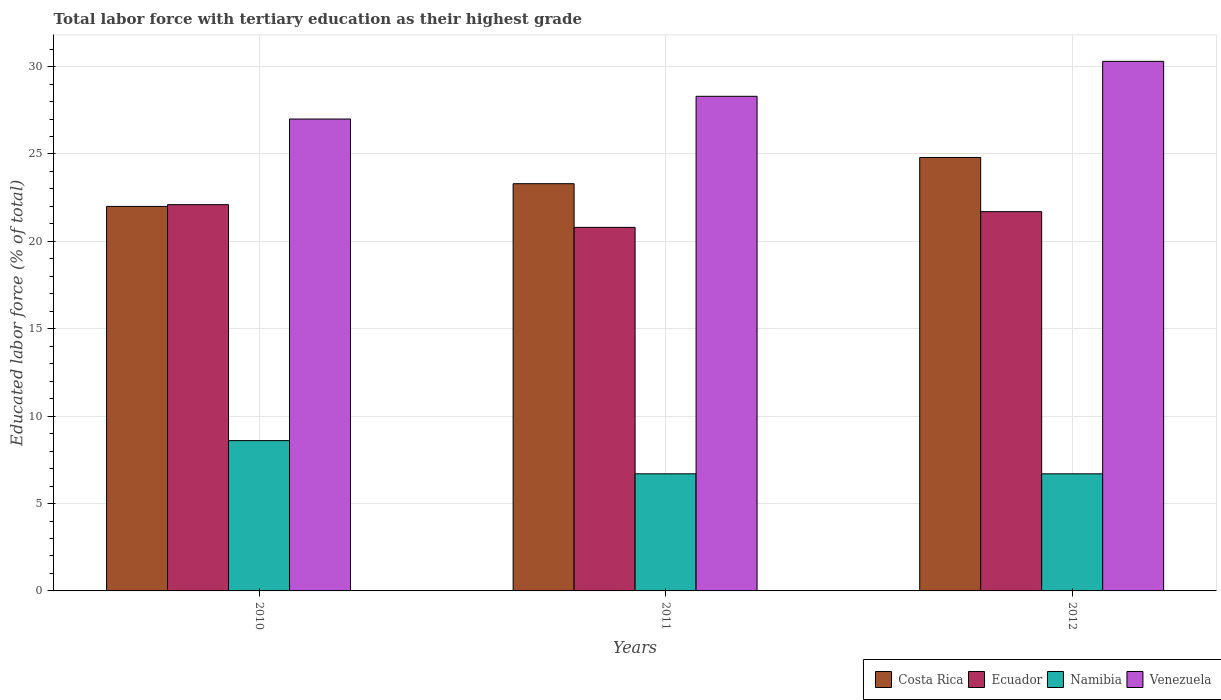How many different coloured bars are there?
Your response must be concise. 4. Are the number of bars on each tick of the X-axis equal?
Make the answer very short. Yes. What is the label of the 3rd group of bars from the left?
Ensure brevity in your answer.  2012. What is the percentage of male labor force with tertiary education in Ecuador in 2011?
Provide a short and direct response. 20.8. Across all years, what is the maximum percentage of male labor force with tertiary education in Venezuela?
Provide a short and direct response. 30.3. Across all years, what is the minimum percentage of male labor force with tertiary education in Ecuador?
Offer a terse response. 20.8. In which year was the percentage of male labor force with tertiary education in Venezuela maximum?
Your answer should be compact. 2012. In which year was the percentage of male labor force with tertiary education in Namibia minimum?
Ensure brevity in your answer.  2011. What is the total percentage of male labor force with tertiary education in Ecuador in the graph?
Your response must be concise. 64.6. What is the difference between the percentage of male labor force with tertiary education in Ecuador in 2010 and that in 2011?
Provide a short and direct response. 1.3. What is the difference between the percentage of male labor force with tertiary education in Venezuela in 2011 and the percentage of male labor force with tertiary education in Costa Rica in 2012?
Ensure brevity in your answer.  3.5. What is the average percentage of male labor force with tertiary education in Venezuela per year?
Make the answer very short. 28.53. In the year 2010, what is the difference between the percentage of male labor force with tertiary education in Namibia and percentage of male labor force with tertiary education in Venezuela?
Your response must be concise. -18.4. What is the ratio of the percentage of male labor force with tertiary education in Ecuador in 2010 to that in 2012?
Make the answer very short. 1.02. What is the difference between the highest and the second highest percentage of male labor force with tertiary education in Namibia?
Ensure brevity in your answer.  1.9. What is the difference between the highest and the lowest percentage of male labor force with tertiary education in Ecuador?
Offer a very short reply. 1.3. In how many years, is the percentage of male labor force with tertiary education in Venezuela greater than the average percentage of male labor force with tertiary education in Venezuela taken over all years?
Keep it short and to the point. 1. What does the 1st bar from the left in 2012 represents?
Ensure brevity in your answer.  Costa Rica. What does the 2nd bar from the right in 2011 represents?
Keep it short and to the point. Namibia. Is it the case that in every year, the sum of the percentage of male labor force with tertiary education in Ecuador and percentage of male labor force with tertiary education in Costa Rica is greater than the percentage of male labor force with tertiary education in Namibia?
Your response must be concise. Yes. How many bars are there?
Ensure brevity in your answer.  12. Are the values on the major ticks of Y-axis written in scientific E-notation?
Make the answer very short. No. What is the title of the graph?
Offer a very short reply. Total labor force with tertiary education as their highest grade. Does "Saudi Arabia" appear as one of the legend labels in the graph?
Your response must be concise. No. What is the label or title of the X-axis?
Keep it short and to the point. Years. What is the label or title of the Y-axis?
Offer a terse response. Educated labor force (% of total). What is the Educated labor force (% of total) in Costa Rica in 2010?
Keep it short and to the point. 22. What is the Educated labor force (% of total) in Ecuador in 2010?
Offer a very short reply. 22.1. What is the Educated labor force (% of total) in Namibia in 2010?
Give a very brief answer. 8.6. What is the Educated labor force (% of total) in Costa Rica in 2011?
Offer a terse response. 23.3. What is the Educated labor force (% of total) in Ecuador in 2011?
Offer a very short reply. 20.8. What is the Educated labor force (% of total) of Namibia in 2011?
Keep it short and to the point. 6.7. What is the Educated labor force (% of total) of Venezuela in 2011?
Offer a very short reply. 28.3. What is the Educated labor force (% of total) in Costa Rica in 2012?
Provide a succinct answer. 24.8. What is the Educated labor force (% of total) in Ecuador in 2012?
Ensure brevity in your answer.  21.7. What is the Educated labor force (% of total) of Namibia in 2012?
Make the answer very short. 6.7. What is the Educated labor force (% of total) in Venezuela in 2012?
Ensure brevity in your answer.  30.3. Across all years, what is the maximum Educated labor force (% of total) of Costa Rica?
Offer a terse response. 24.8. Across all years, what is the maximum Educated labor force (% of total) of Ecuador?
Your response must be concise. 22.1. Across all years, what is the maximum Educated labor force (% of total) in Namibia?
Your response must be concise. 8.6. Across all years, what is the maximum Educated labor force (% of total) in Venezuela?
Your answer should be compact. 30.3. Across all years, what is the minimum Educated labor force (% of total) of Costa Rica?
Provide a succinct answer. 22. Across all years, what is the minimum Educated labor force (% of total) in Ecuador?
Your answer should be compact. 20.8. Across all years, what is the minimum Educated labor force (% of total) in Namibia?
Offer a very short reply. 6.7. Across all years, what is the minimum Educated labor force (% of total) of Venezuela?
Give a very brief answer. 27. What is the total Educated labor force (% of total) in Costa Rica in the graph?
Provide a succinct answer. 70.1. What is the total Educated labor force (% of total) in Ecuador in the graph?
Make the answer very short. 64.6. What is the total Educated labor force (% of total) of Venezuela in the graph?
Provide a succinct answer. 85.6. What is the difference between the Educated labor force (% of total) in Costa Rica in 2010 and that in 2011?
Provide a short and direct response. -1.3. What is the difference between the Educated labor force (% of total) of Namibia in 2010 and that in 2011?
Give a very brief answer. 1.9. What is the difference between the Educated labor force (% of total) in Costa Rica in 2010 and that in 2012?
Ensure brevity in your answer.  -2.8. What is the difference between the Educated labor force (% of total) in Venezuela in 2010 and that in 2012?
Your answer should be compact. -3.3. What is the difference between the Educated labor force (% of total) in Costa Rica in 2010 and the Educated labor force (% of total) in Namibia in 2011?
Provide a short and direct response. 15.3. What is the difference between the Educated labor force (% of total) in Ecuador in 2010 and the Educated labor force (% of total) in Venezuela in 2011?
Offer a terse response. -6.2. What is the difference between the Educated labor force (% of total) of Namibia in 2010 and the Educated labor force (% of total) of Venezuela in 2011?
Offer a terse response. -19.7. What is the difference between the Educated labor force (% of total) of Costa Rica in 2010 and the Educated labor force (% of total) of Venezuela in 2012?
Provide a succinct answer. -8.3. What is the difference between the Educated labor force (% of total) of Ecuador in 2010 and the Educated labor force (% of total) of Namibia in 2012?
Ensure brevity in your answer.  15.4. What is the difference between the Educated labor force (% of total) of Ecuador in 2010 and the Educated labor force (% of total) of Venezuela in 2012?
Your answer should be compact. -8.2. What is the difference between the Educated labor force (% of total) in Namibia in 2010 and the Educated labor force (% of total) in Venezuela in 2012?
Your response must be concise. -21.7. What is the difference between the Educated labor force (% of total) in Costa Rica in 2011 and the Educated labor force (% of total) in Ecuador in 2012?
Ensure brevity in your answer.  1.6. What is the difference between the Educated labor force (% of total) of Ecuador in 2011 and the Educated labor force (% of total) of Namibia in 2012?
Your response must be concise. 14.1. What is the difference between the Educated labor force (% of total) of Namibia in 2011 and the Educated labor force (% of total) of Venezuela in 2012?
Give a very brief answer. -23.6. What is the average Educated labor force (% of total) of Costa Rica per year?
Make the answer very short. 23.37. What is the average Educated labor force (% of total) of Ecuador per year?
Offer a terse response. 21.53. What is the average Educated labor force (% of total) of Namibia per year?
Keep it short and to the point. 7.33. What is the average Educated labor force (% of total) of Venezuela per year?
Offer a very short reply. 28.53. In the year 2010, what is the difference between the Educated labor force (% of total) of Costa Rica and Educated labor force (% of total) of Ecuador?
Give a very brief answer. -0.1. In the year 2010, what is the difference between the Educated labor force (% of total) of Costa Rica and Educated labor force (% of total) of Namibia?
Provide a short and direct response. 13.4. In the year 2010, what is the difference between the Educated labor force (% of total) in Ecuador and Educated labor force (% of total) in Namibia?
Your answer should be compact. 13.5. In the year 2010, what is the difference between the Educated labor force (% of total) of Ecuador and Educated labor force (% of total) of Venezuela?
Give a very brief answer. -4.9. In the year 2010, what is the difference between the Educated labor force (% of total) in Namibia and Educated labor force (% of total) in Venezuela?
Provide a succinct answer. -18.4. In the year 2011, what is the difference between the Educated labor force (% of total) in Ecuador and Educated labor force (% of total) in Namibia?
Give a very brief answer. 14.1. In the year 2011, what is the difference between the Educated labor force (% of total) of Ecuador and Educated labor force (% of total) of Venezuela?
Offer a very short reply. -7.5. In the year 2011, what is the difference between the Educated labor force (% of total) of Namibia and Educated labor force (% of total) of Venezuela?
Provide a short and direct response. -21.6. In the year 2012, what is the difference between the Educated labor force (% of total) of Costa Rica and Educated labor force (% of total) of Venezuela?
Offer a very short reply. -5.5. In the year 2012, what is the difference between the Educated labor force (% of total) in Namibia and Educated labor force (% of total) in Venezuela?
Provide a short and direct response. -23.6. What is the ratio of the Educated labor force (% of total) in Costa Rica in 2010 to that in 2011?
Keep it short and to the point. 0.94. What is the ratio of the Educated labor force (% of total) of Ecuador in 2010 to that in 2011?
Provide a short and direct response. 1.06. What is the ratio of the Educated labor force (% of total) in Namibia in 2010 to that in 2011?
Keep it short and to the point. 1.28. What is the ratio of the Educated labor force (% of total) in Venezuela in 2010 to that in 2011?
Give a very brief answer. 0.95. What is the ratio of the Educated labor force (% of total) of Costa Rica in 2010 to that in 2012?
Offer a very short reply. 0.89. What is the ratio of the Educated labor force (% of total) of Ecuador in 2010 to that in 2012?
Your response must be concise. 1.02. What is the ratio of the Educated labor force (% of total) of Namibia in 2010 to that in 2012?
Provide a succinct answer. 1.28. What is the ratio of the Educated labor force (% of total) of Venezuela in 2010 to that in 2012?
Keep it short and to the point. 0.89. What is the ratio of the Educated labor force (% of total) in Costa Rica in 2011 to that in 2012?
Keep it short and to the point. 0.94. What is the ratio of the Educated labor force (% of total) of Ecuador in 2011 to that in 2012?
Make the answer very short. 0.96. What is the ratio of the Educated labor force (% of total) of Namibia in 2011 to that in 2012?
Offer a very short reply. 1. What is the ratio of the Educated labor force (% of total) of Venezuela in 2011 to that in 2012?
Your answer should be very brief. 0.93. What is the difference between the highest and the second highest Educated labor force (% of total) in Namibia?
Give a very brief answer. 1.9. What is the difference between the highest and the second highest Educated labor force (% of total) in Venezuela?
Offer a very short reply. 2. What is the difference between the highest and the lowest Educated labor force (% of total) of Costa Rica?
Your answer should be compact. 2.8. What is the difference between the highest and the lowest Educated labor force (% of total) in Namibia?
Your response must be concise. 1.9. What is the difference between the highest and the lowest Educated labor force (% of total) of Venezuela?
Keep it short and to the point. 3.3. 